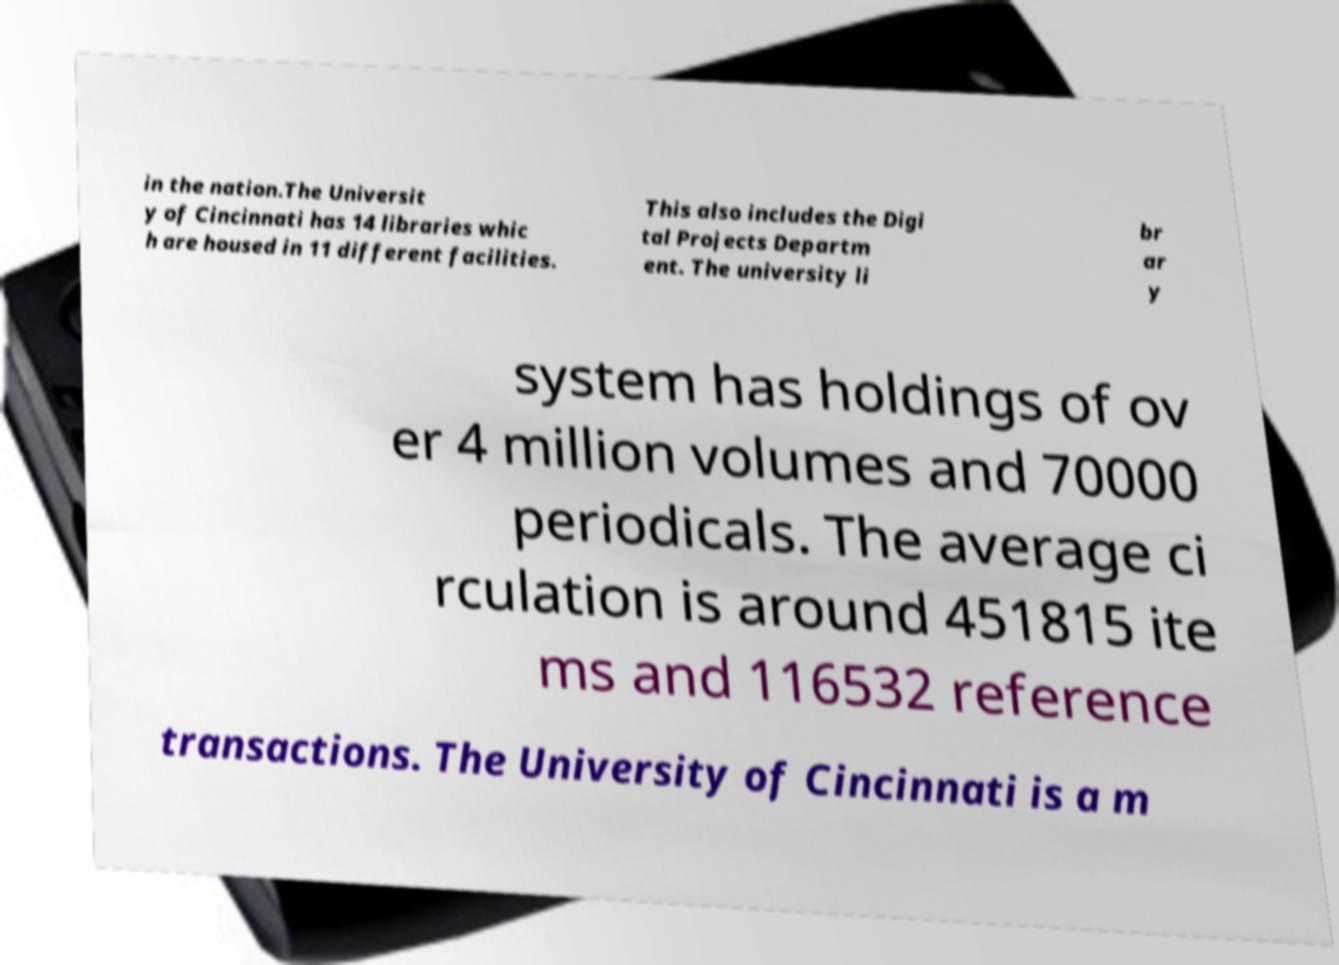Could you extract and type out the text from this image? in the nation.The Universit y of Cincinnati has 14 libraries whic h are housed in 11 different facilities. This also includes the Digi tal Projects Departm ent. The university li br ar y system has holdings of ov er 4 million volumes and 70000 periodicals. The average ci rculation is around 451815 ite ms and 116532 reference transactions. The University of Cincinnati is a m 